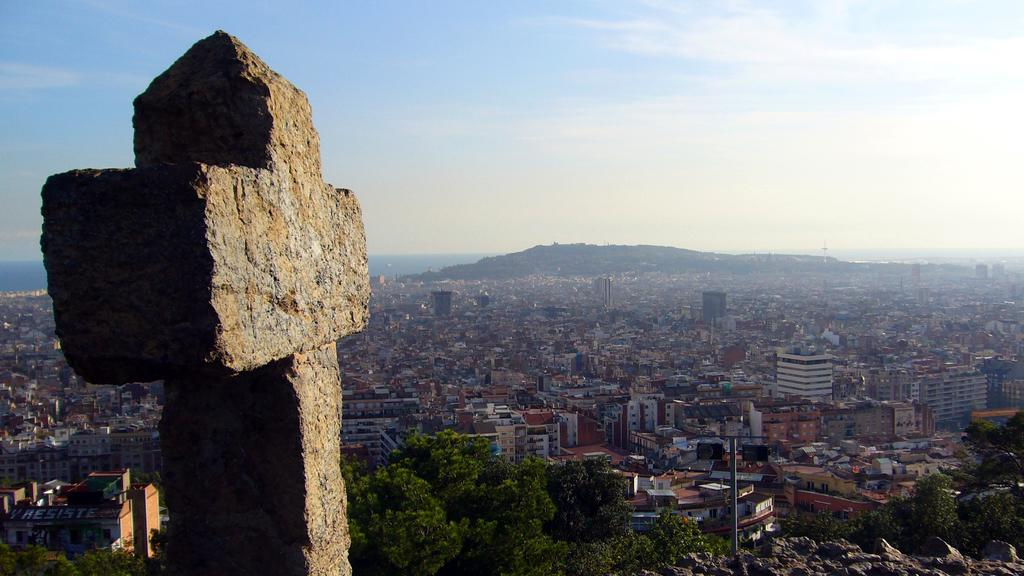What shape is the stone in the foreground of the image? The stone in the foreground of the image is in the shape of a cross. What can be seen in the background of the image? There are trees, a city, water, a cliff, and the sky visible in the background of the image. What is the condition of the sky in the image? The sky is visible in the background of the image, and clouds are present. What type of bread can be seen floating in the water in the image? There is no bread present in the image, and no bread is floating in the water. 